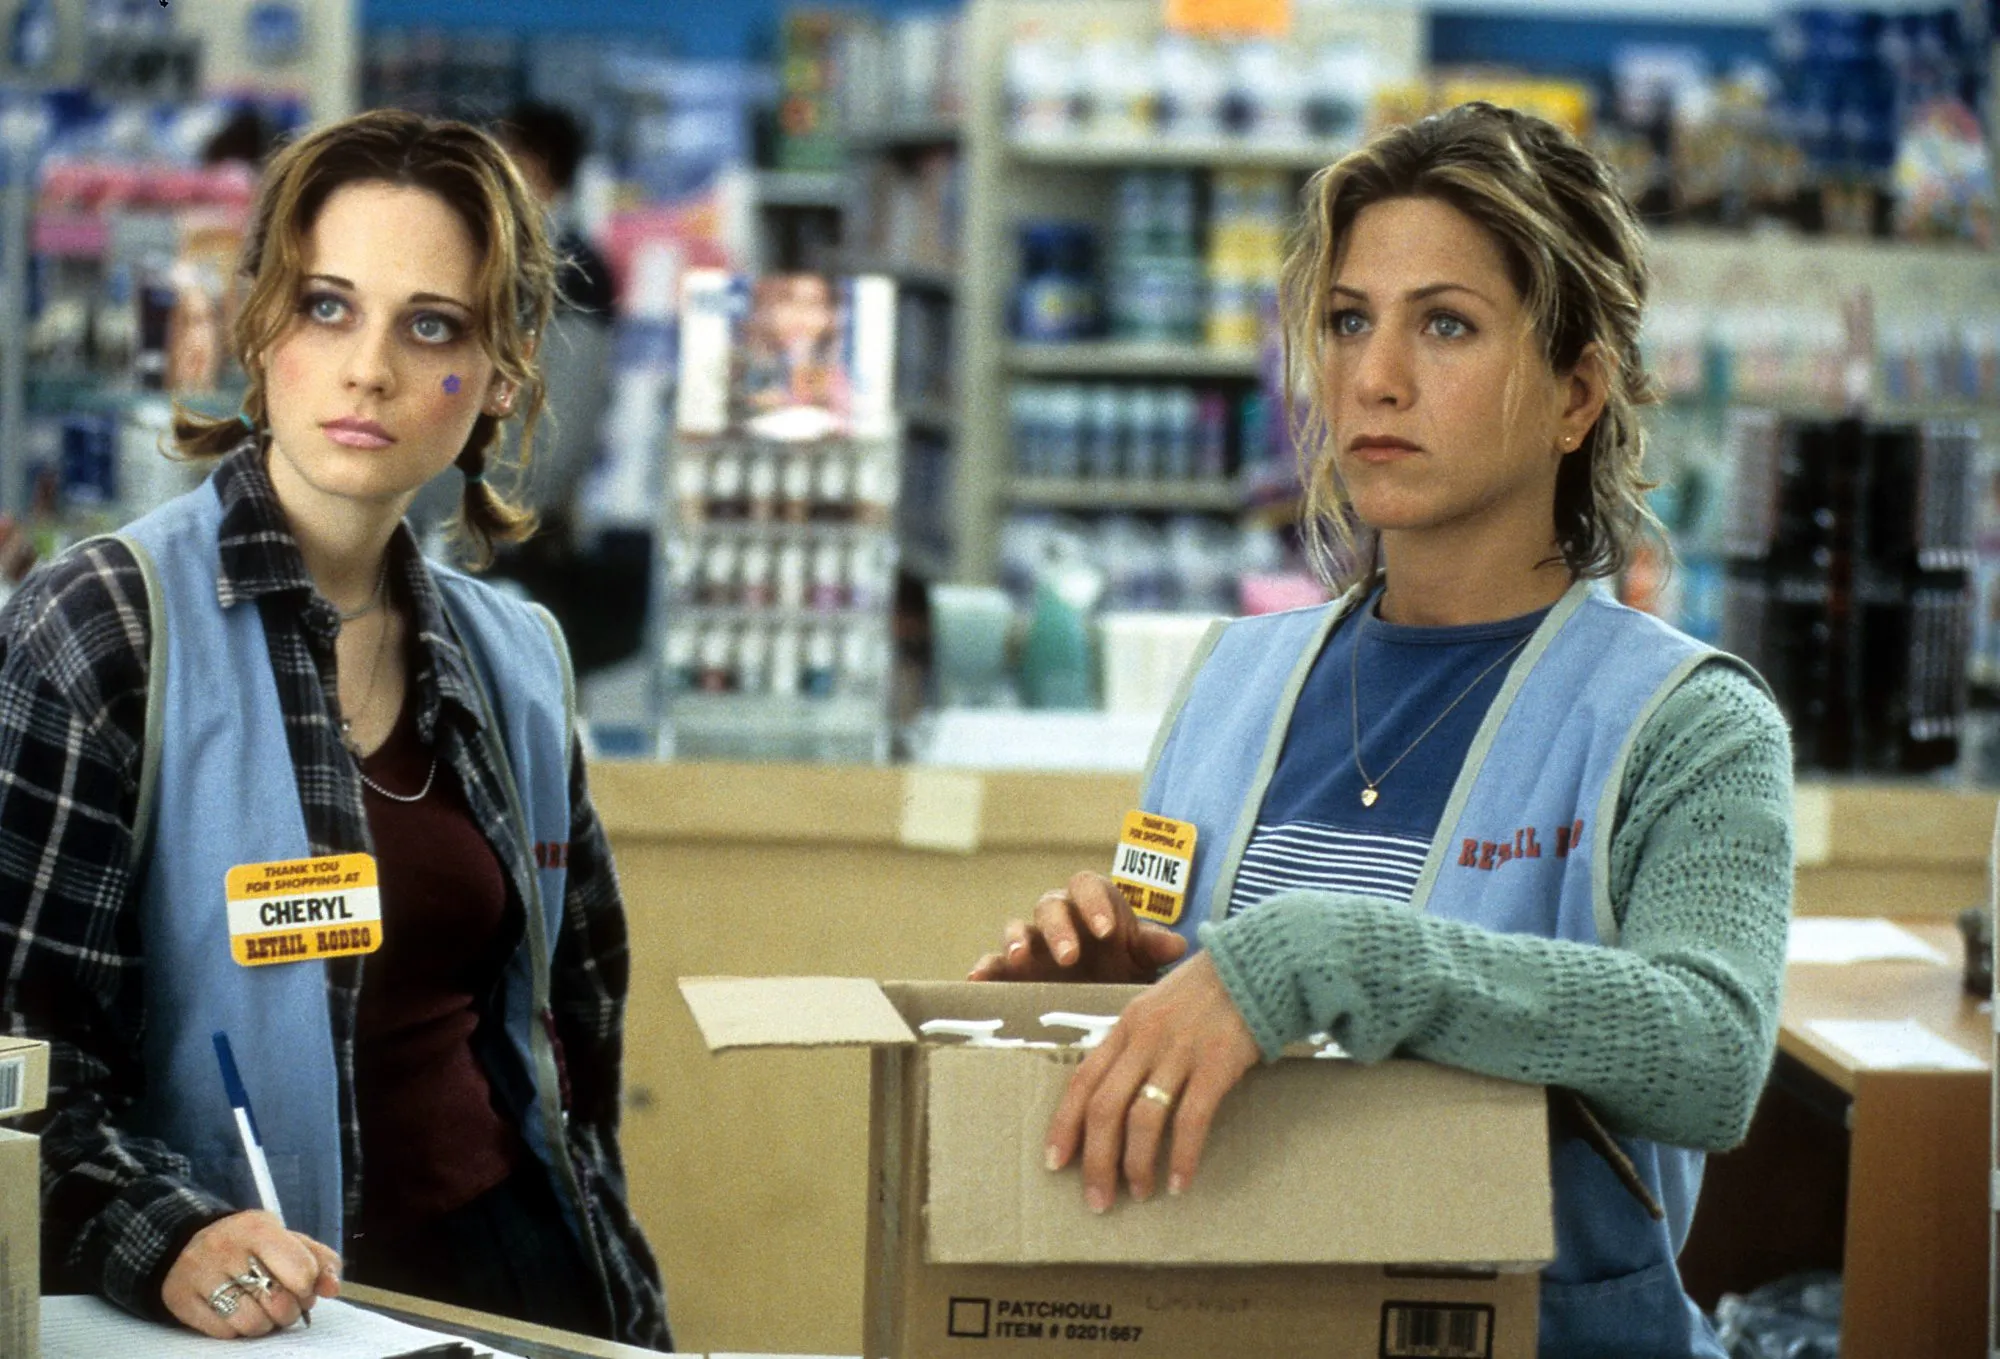What items are being stocked in the store? The store in the image seems to stock a variety of everyday products. There are shelves in the background filled with what appear to be toiletries, personal care items, and other general goods. The box held by Jennifer Aniston contains boxed items labeled 'Patchouli,' likely indicating it contains scented products or essential oils. 